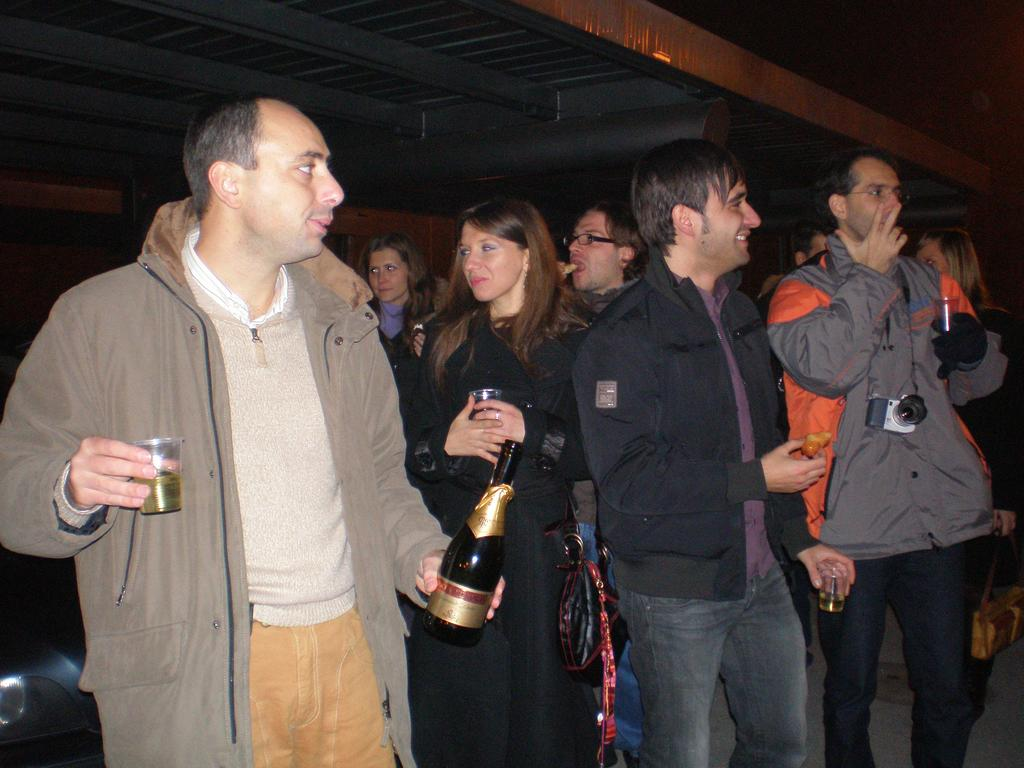What is happening in the image? There are people standing in the image. Can you describe the man on the left side of the image? The man on the left side of the image is holding a wine bottle and a glass. What type of plot is the man on the left side of the image standing on? There is no plot or ground surface mentioned in the image, so it cannot be determined what type of plot the man is standing on. 